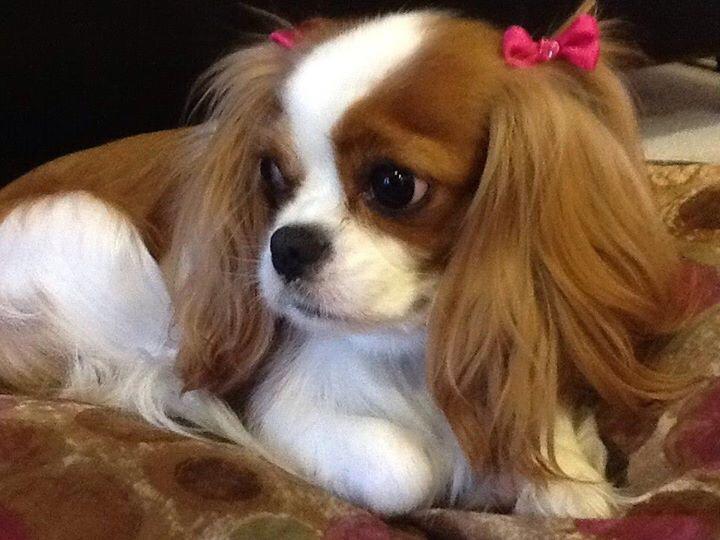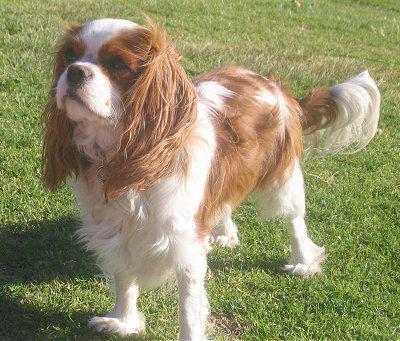The first image is the image on the left, the second image is the image on the right. Assess this claim about the two images: "The dog on the right is standing in the green grass outside.". Correct or not? Answer yes or no. Yes. The first image is the image on the left, the second image is the image on the right. Analyze the images presented: Is the assertion "Left and right images feature one dog on the same type of surface as in the other image." valid? Answer yes or no. No. 